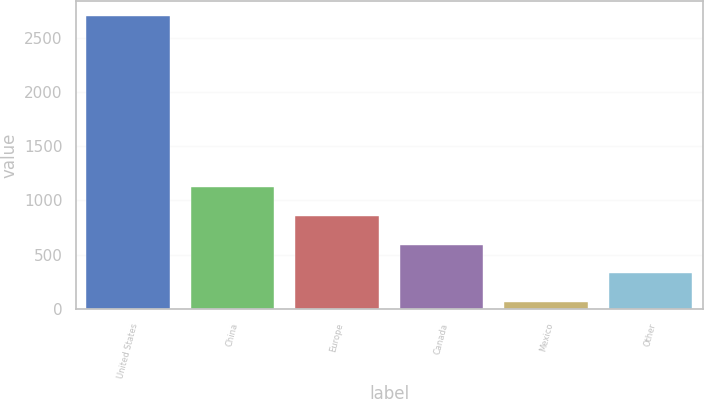Convert chart to OTSL. <chart><loc_0><loc_0><loc_500><loc_500><bar_chart><fcel>United States<fcel>China<fcel>Europe<fcel>Canada<fcel>Mexico<fcel>Other<nl><fcel>2705.9<fcel>1121.06<fcel>856.92<fcel>592.78<fcel>64.5<fcel>328.64<nl></chart> 